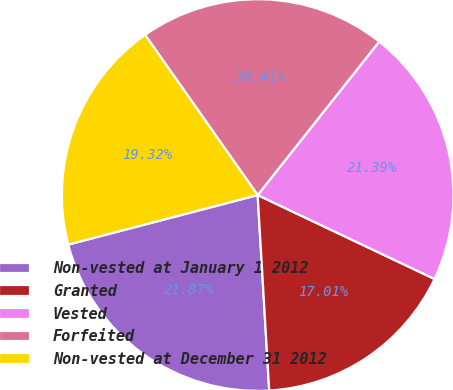<chart> <loc_0><loc_0><loc_500><loc_500><pie_chart><fcel>Non-vested at January 1 2012<fcel>Granted<fcel>Vested<fcel>Forfeited<fcel>Non-vested at December 31 2012<nl><fcel>21.87%<fcel>17.01%<fcel>21.39%<fcel>20.41%<fcel>19.32%<nl></chart> 